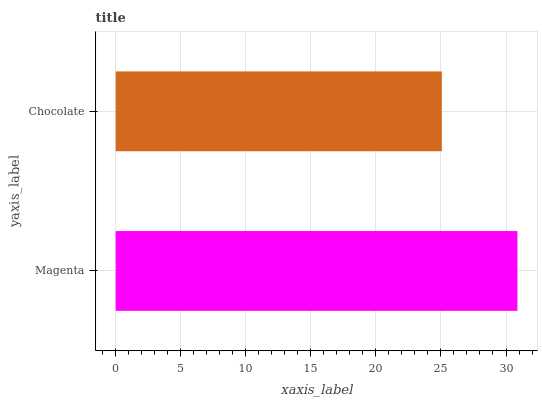Is Chocolate the minimum?
Answer yes or no. Yes. Is Magenta the maximum?
Answer yes or no. Yes. Is Chocolate the maximum?
Answer yes or no. No. Is Magenta greater than Chocolate?
Answer yes or no. Yes. Is Chocolate less than Magenta?
Answer yes or no. Yes. Is Chocolate greater than Magenta?
Answer yes or no. No. Is Magenta less than Chocolate?
Answer yes or no. No. Is Magenta the high median?
Answer yes or no. Yes. Is Chocolate the low median?
Answer yes or no. Yes. Is Chocolate the high median?
Answer yes or no. No. Is Magenta the low median?
Answer yes or no. No. 